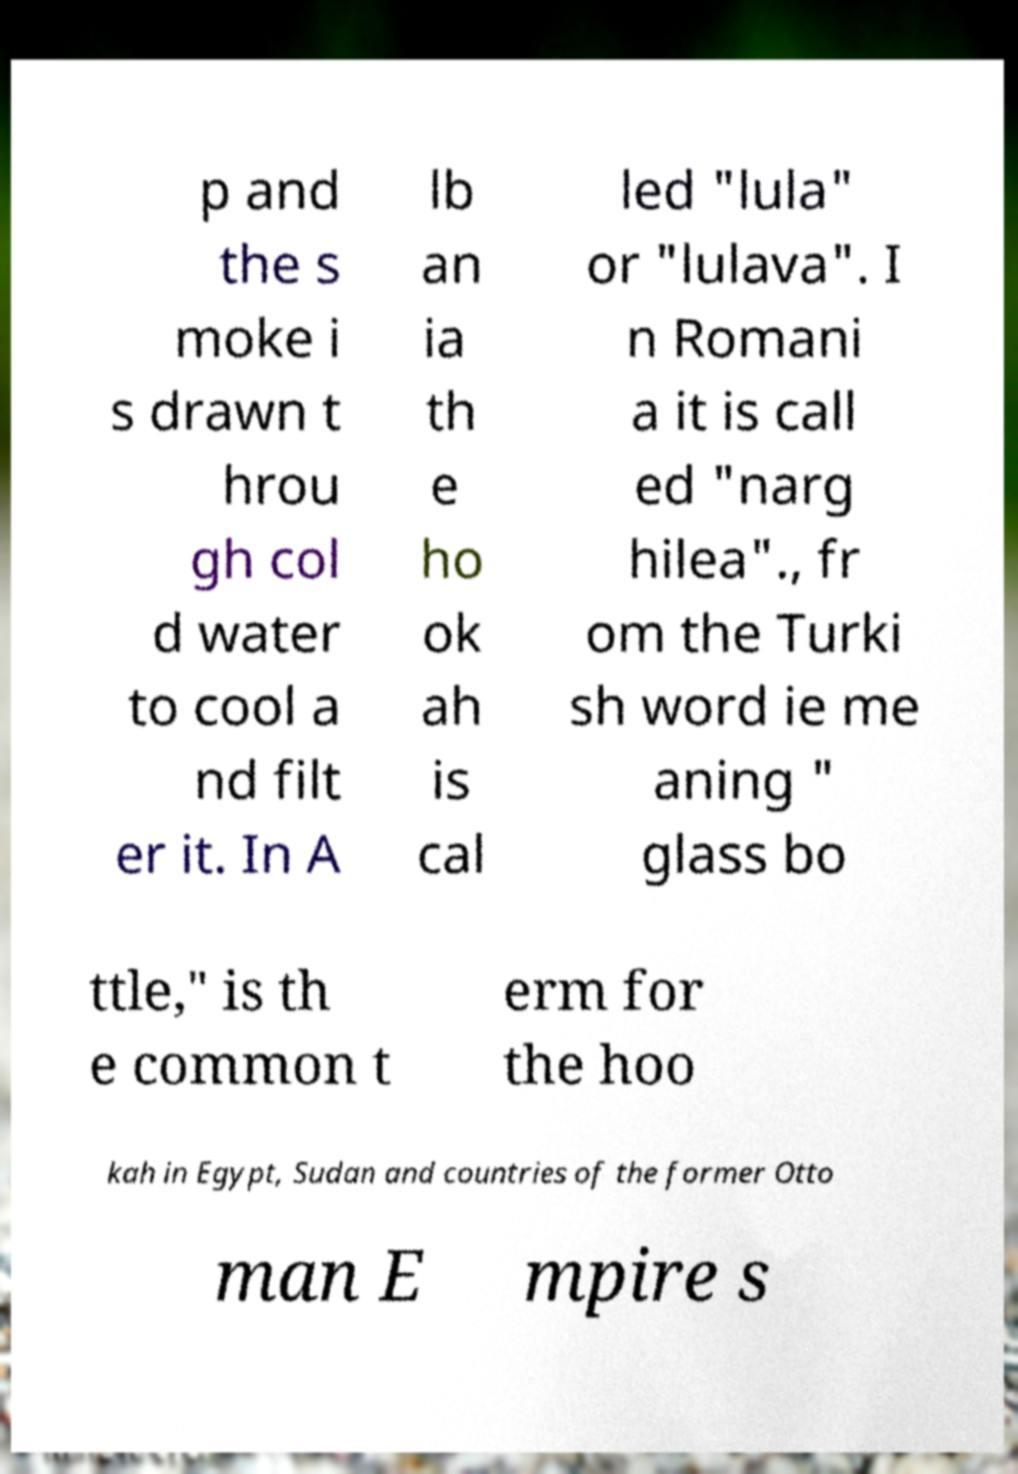Could you extract and type out the text from this image? p and the s moke i s drawn t hrou gh col d water to cool a nd filt er it. In A lb an ia th e ho ok ah is cal led "lula" or "lulava". I n Romani a it is call ed "narg hilea"., fr om the Turki sh word ie me aning " glass bo ttle," is th e common t erm for the hoo kah in Egypt, Sudan and countries of the former Otto man E mpire s 